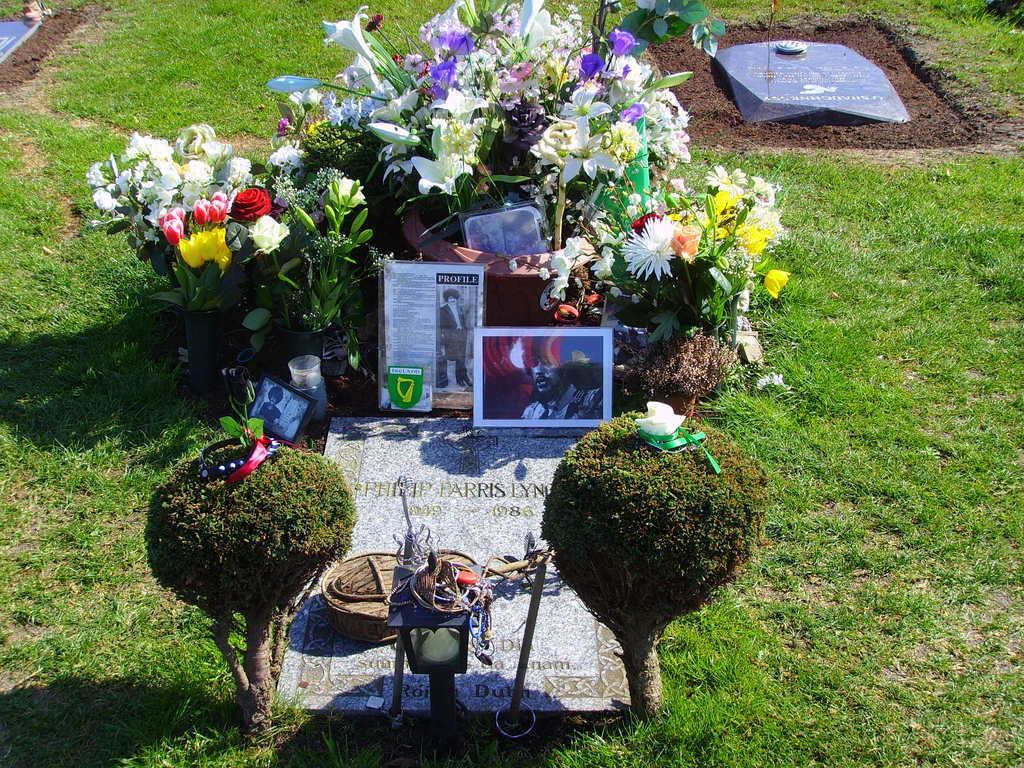In one or two sentences, can you explain what this image depicts? In this picture we can see some flowers and photo frames, placed on the person's grave. Beside we can see the another grave and grass lawn. 